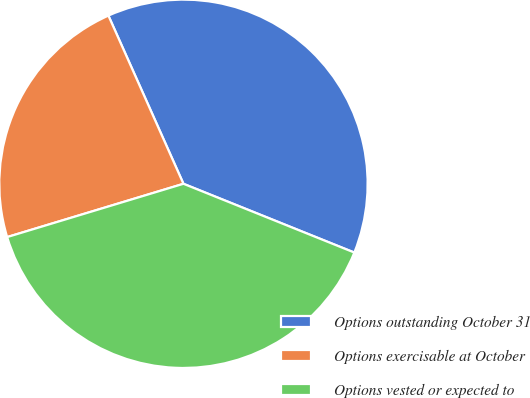Convert chart. <chart><loc_0><loc_0><loc_500><loc_500><pie_chart><fcel>Options outstanding October 31<fcel>Options exercisable at October<fcel>Options vested or expected to<nl><fcel>37.77%<fcel>22.99%<fcel>39.24%<nl></chart> 